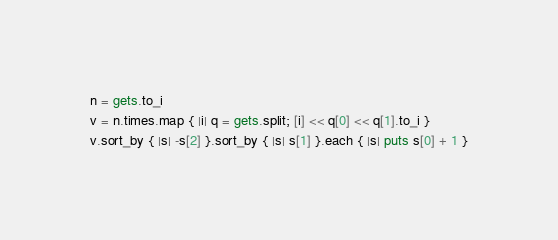<code> <loc_0><loc_0><loc_500><loc_500><_Ruby_>n = gets.to_i
v = n.times.map { |i| q = gets.split; [i] << q[0] << q[1].to_i }
v.sort_by { |s| -s[2] }.sort_by { |s| s[1] }.each { |s| puts s[0] + 1 }</code> 